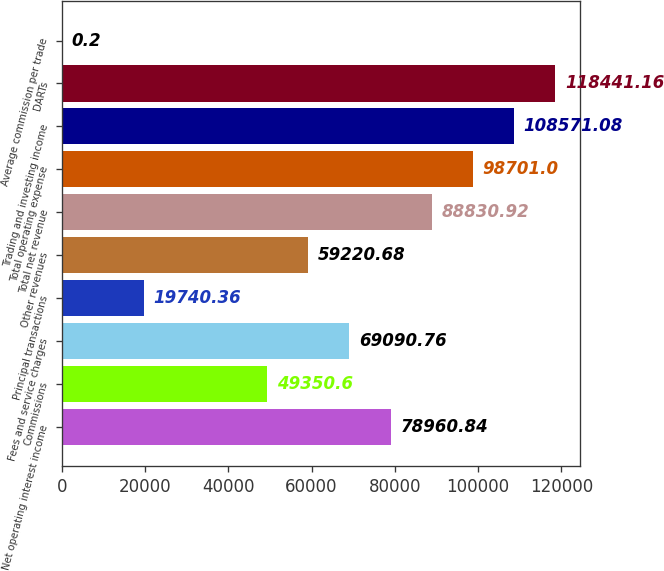<chart> <loc_0><loc_0><loc_500><loc_500><bar_chart><fcel>Net operating interest income<fcel>Commissions<fcel>Fees and service charges<fcel>Principal transactions<fcel>Other revenues<fcel>Total net revenue<fcel>Total operating expense<fcel>Trading and investing income<fcel>DARTs<fcel>Average commission per trade<nl><fcel>78960.8<fcel>49350.6<fcel>69090.8<fcel>19740.4<fcel>59220.7<fcel>88830.9<fcel>98701<fcel>108571<fcel>118441<fcel>0.2<nl></chart> 